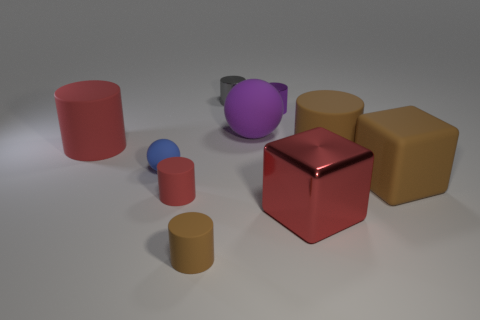Does the brown cylinder left of the big shiny thing have the same size as the rubber ball that is right of the gray metallic cylinder?
Ensure brevity in your answer.  No. There is a red cylinder that is the same size as the gray object; what is it made of?
Your answer should be very brief. Rubber. How many other objects are there of the same material as the large ball?
Offer a terse response. 6. Is the shape of the large red object to the left of the big red shiny block the same as the large red object on the right side of the purple matte sphere?
Make the answer very short. No. There is a large cylinder behind the big brown matte thing behind the blue sphere left of the large red metallic cube; what color is it?
Provide a short and direct response. Red. What number of other things are there of the same color as the small ball?
Offer a terse response. 0. Is the number of big purple things less than the number of yellow metal cubes?
Offer a very short reply. No. There is a object that is in front of the tiny red matte cylinder and left of the purple matte object; what color is it?
Provide a short and direct response. Brown. What is the material of the big purple object that is the same shape as the small blue matte object?
Keep it short and to the point. Rubber. Is there any other thing that has the same size as the brown cube?
Keep it short and to the point. Yes. 